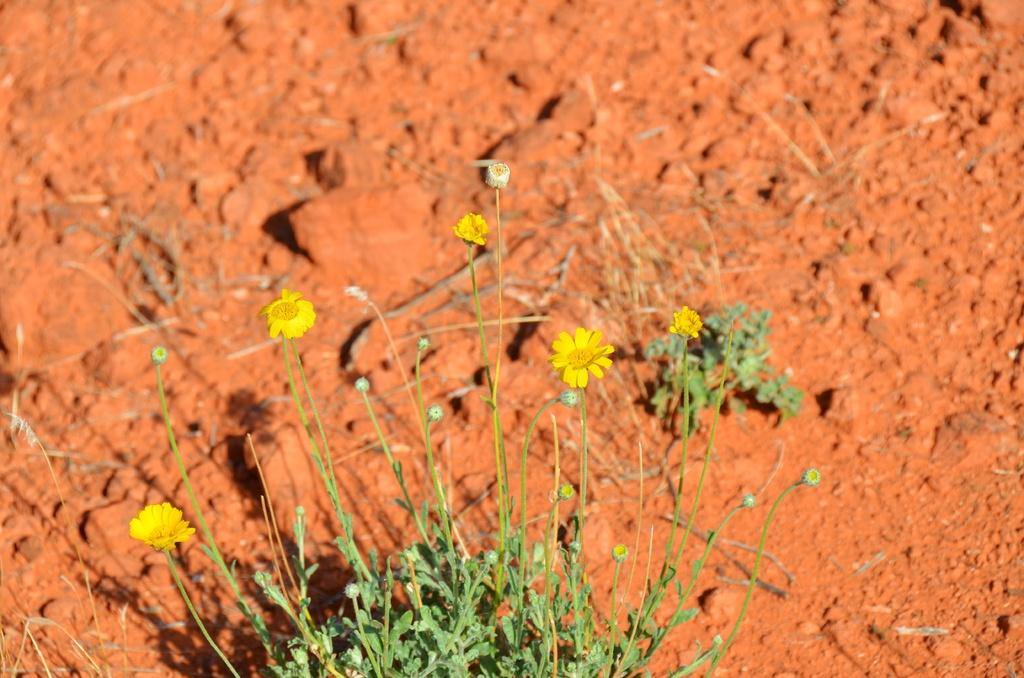What type of plant is in the image? There is a plant in the image, but the specific type is not mentioned. What can be seen on the plant? The plant has flowers. What color are the flowers? The flowers are yellow. What can be seen in the background of the image? There is soil visible in the background of the image. What is the color of the soil? The soil is brown in color. What type of muscle can be seen flexing in the image? There is no muscle visible in the image; it features a plant with yellow flowers and brown soil. 